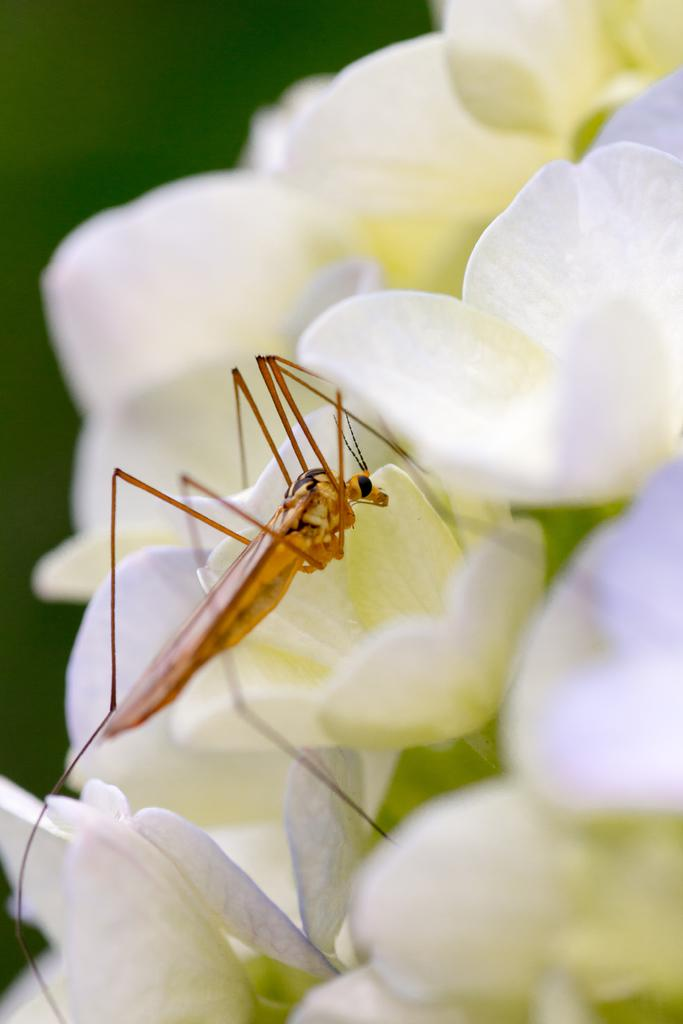What type of flowers are present in the image? There are white flowers in the image. Is there anything else on the flowers besides the flowers themselves? Yes, there is an insect on the flowers. Can you describe the background of the image? The background of the image is blurred. What type of powder can be seen falling from the sky in the image? There is no powder falling from the sky in the image; it only features white flowers, an insect, and a blurred background. 